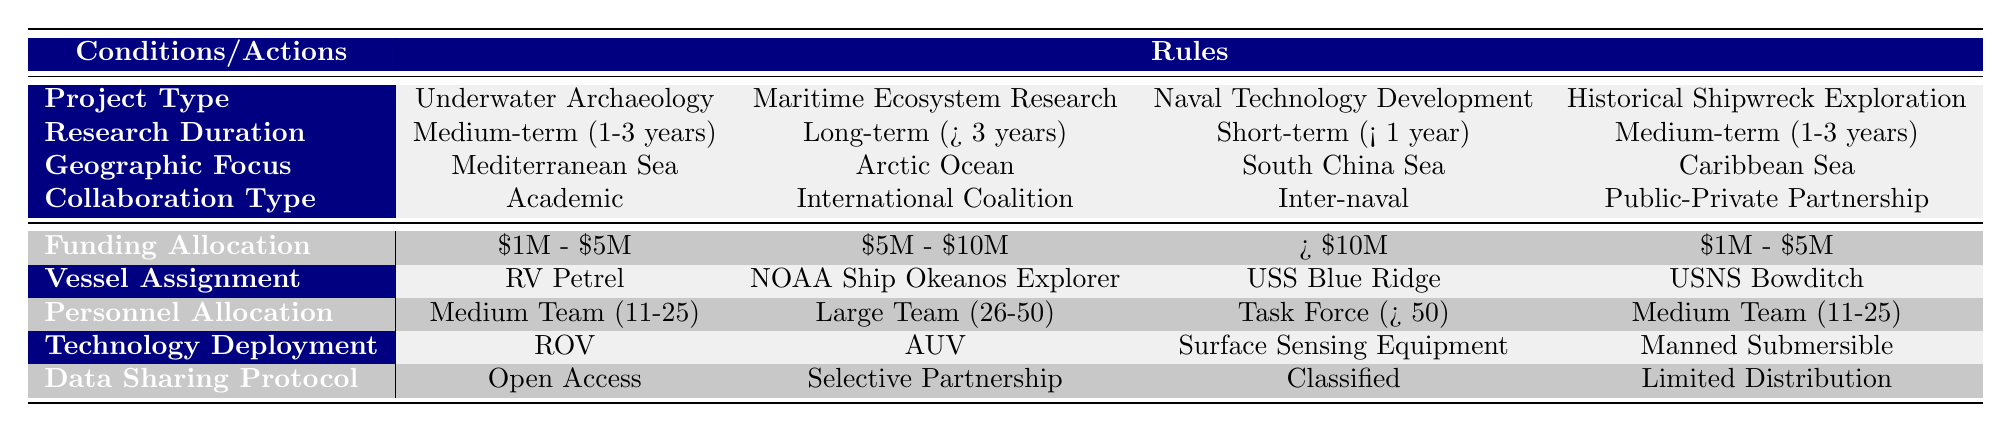What is the funding allocation for Maritime Ecosystem Research projects? According to the table, the funding allocation for Maritime Ecosystem Research projects is in the range of 5 million to 10 million dollars.
Answer: 5 million to 10 million dollars Which vessel is assigned to Historical Shipwreck Exploration? The table specifies that the vessel assigned to Historical Shipwreck Exploration is the USNS Bowditch.
Answer: USNS Bowditch Is the personnel allocation for Underwater Archaeology a medium team? The table indicates that the personnel allocation for Underwater Archaeology is a medium team, consisting of 11 to 25 personnel.
Answer: Yes What is the technology deployed for Naval Technology Development? The technology deployed for Naval Technology Development is Surface Sensing Equipment, as indicated by the table.
Answer: Surface Sensing Equipment For the Maritime Ecosystem Research project in the Arctic Ocean, what is the data sharing protocol? The table shows that the data sharing protocol for Maritime Ecosystem Research in the Arctic Ocean is Selective Partnership.
Answer: Selective Partnership What is the relationship between Research Duration and Funding Allocation for Historical Shipwreck Exploration? For Historical Shipwreck Exploration, the Research Duration is medium-term (1-3 years) which corresponds to a funding allocation of 1 million to 5 million dollars. So, the two are directly linked in the table.
Answer: Medium-term (1-3 years) corresponds to 1 million to 5 million dollars Compare the personnel allocations for the different projects. What is the total range of teams involved? The personnel allocations are: Medium Team for Underwater Archaeology, Large Team for Maritime Ecosystem Research, Task Force for Naval Technology Development, and Medium Team for Historical Shipwreck Exploration. This means the total range (from smallest to largest team) is 11 to 50 personnel.
Answer: 11 to 50 personnel Is the research duration for all projects short-term? No, the research duration varies: Medium-term for Underwater Archaeology and Historical Shipwreck Exploration, Long-term for Maritime Ecosystem Research, and Short-term for Naval Technology Development.
Answer: No What combination of project type and geographic focus results in a task force personnel allocation? The table shows that only the Naval Technology Development project in the South China Sea has a Task Force allocation, therefore the combination is Naval Technology Development and South China Sea.
Answer: Naval Technology Development and South China Sea 